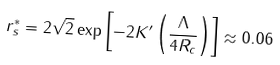<formula> <loc_0><loc_0><loc_500><loc_500>r _ { s } ^ { \ast } = 2 \sqrt { 2 } \exp \left [ - 2 K ^ { \prime } \left ( \frac { \Lambda } { 4 R _ { c } } \right ) \right ] \approx 0 . 0 6</formula> 